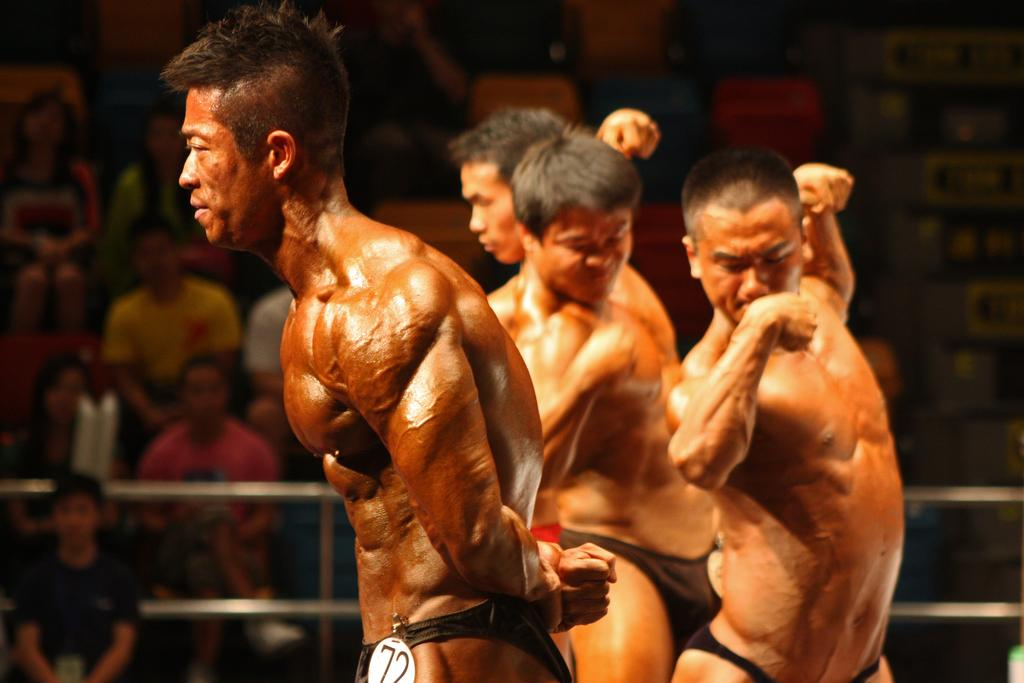What type of people can be seen in the image? There are bodybuilders in the image. What are the bodybuilders doing in the image? The bodybuilders are showing their muscles. What can be seen in the background of the image? There is railing and people sitting on chairs in the background of the image. What type of shoes are the bodybuilders wearing in the image? There is no information about shoes in the image, as the focus is on the bodybuilders showing their muscles. 